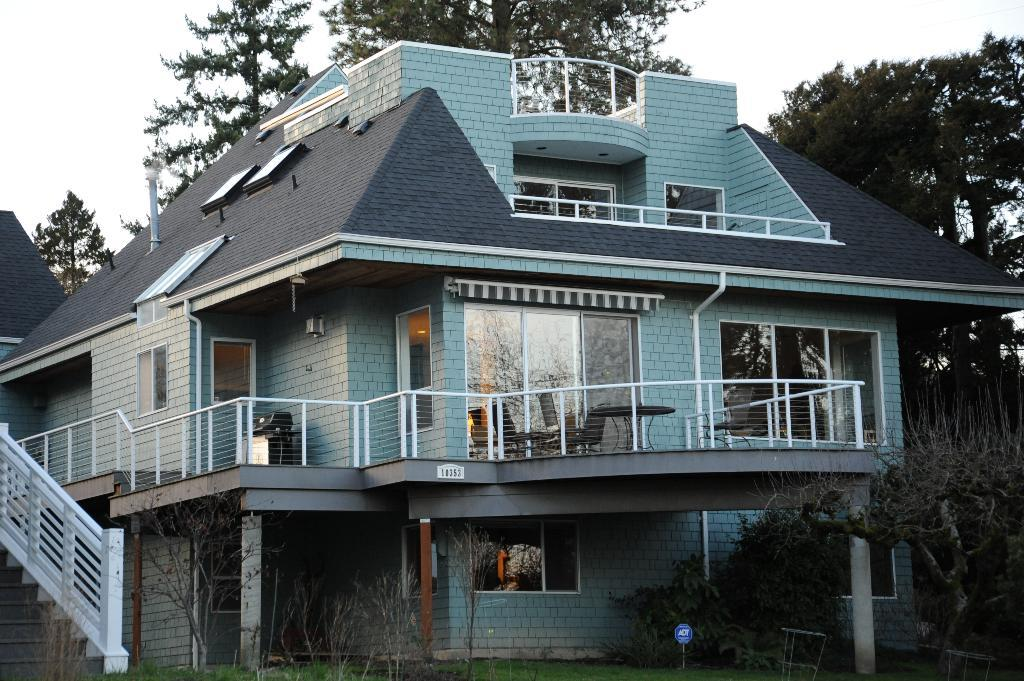What type of structure is visible in the image? There is a building in the image. What type of furniture is present in the image? There are chairs and a table in the image. What type of natural environment is visible in the image? Grass, trees, and the sky are visible in the image. How many hours of sleep can be seen in the image? There is no indication of sleep or time in the image, so it cannot be determined. 